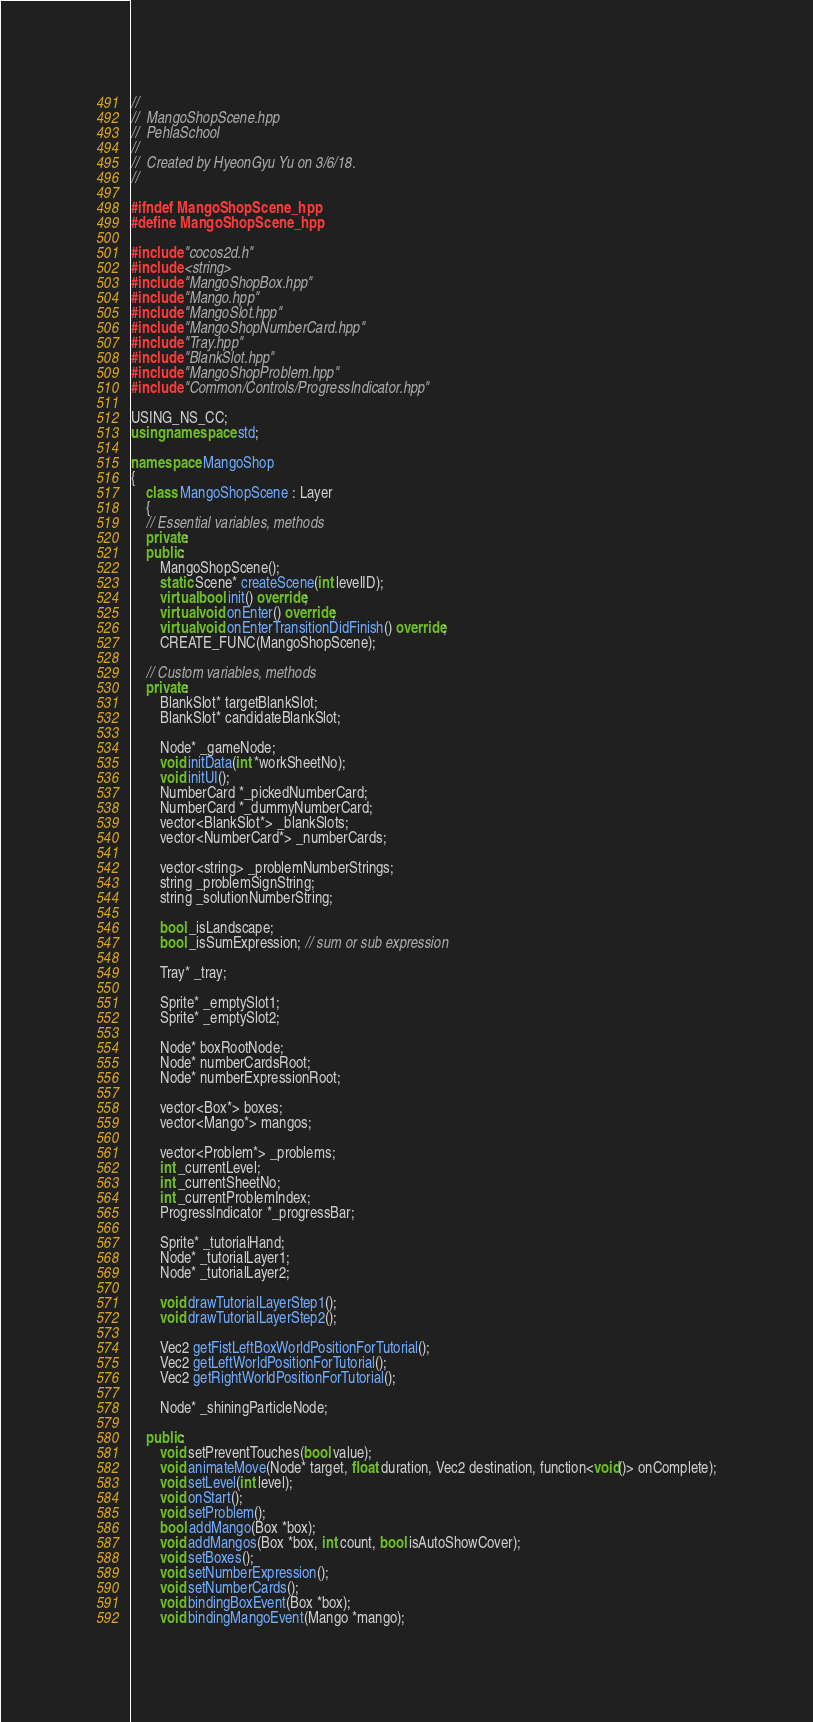<code> <loc_0><loc_0><loc_500><loc_500><_C++_>//
//  MangoShopScene.hpp
//  PehlaSchool
//
//  Created by HyeonGyu Yu on 3/6/18.
//

#ifndef MangoShopScene_hpp
#define MangoShopScene_hpp

#include "cocos2d.h"
#include <string>
#include "MangoShopBox.hpp"
#include "Mango.hpp"
#include "MangoSlot.hpp"
#include "MangoShopNumberCard.hpp"
#include "Tray.hpp"
#include "BlankSlot.hpp"
#include "MangoShopProblem.hpp"
#include "Common/Controls/ProgressIndicator.hpp"

USING_NS_CC;
using namespace std;

namespace MangoShop
{
    class MangoShopScene : Layer
    {
    // Essential variables, methods
    private:
    public:
        MangoShopScene();
        static Scene* createScene(int levelID);
        virtual bool init() override;
        virtual void onEnter() override;
        virtual void onEnterTransitionDidFinish() override;
        CREATE_FUNC(MangoShopScene);
        
    // Custom variables, methods
    private:
        BlankSlot* targetBlankSlot;
        BlankSlot* candidateBlankSlot;
        
        Node* _gameNode;
        void initData(int *workSheetNo);
        void initUI();
        NumberCard *_pickedNumberCard;
        NumberCard *_dummyNumberCard;
        vector<BlankSlot*> _blankSlots;
        vector<NumberCard*> _numberCards;
        
        vector<string> _problemNumberStrings;
        string _problemSignString;
        string _solutionNumberString;
        
        bool _isLandscape;
        bool _isSumExpression; // sum or sub expression
        
        Tray* _tray;
        
        Sprite* _emptySlot1;
        Sprite* _emptySlot2;

        Node* boxRootNode;
        Node* numberCardsRoot;
        Node* numberExpressionRoot;
        
        vector<Box*> boxes;
        vector<Mango*> mangos;

        vector<Problem*> _problems;
        int _currentLevel;
        int _currentSheetNo;
        int _currentProblemIndex;
        ProgressIndicator *_progressBar;
        
        Sprite* _tutorialHand;
        Node* _tutorialLayer1;
        Node* _tutorialLayer2;
        
        void drawTutorialLayerStep1();
        void drawTutorialLayerStep2();
        
        Vec2 getFistLeftBoxWorldPositionForTutorial();
        Vec2 getLeftWorldPositionForTutorial();
        Vec2 getRightWorldPositionForTutorial();
        
        Node* _shiningParticleNode;
        
    public:
        void setPreventTouches(bool value);
        void animateMove(Node* target, float duration, Vec2 destination, function<void()> onComplete);
        void setLevel(int level);
        void onStart();
        void setProblem();
        bool addMango(Box *box);
        void addMangos(Box *box, int count, bool isAutoShowCover);
        void setBoxes();
        void setNumberExpression();
        void setNumberCards();
        void bindingBoxEvent(Box *box);
        void bindingMangoEvent(Mango *mango);</code> 